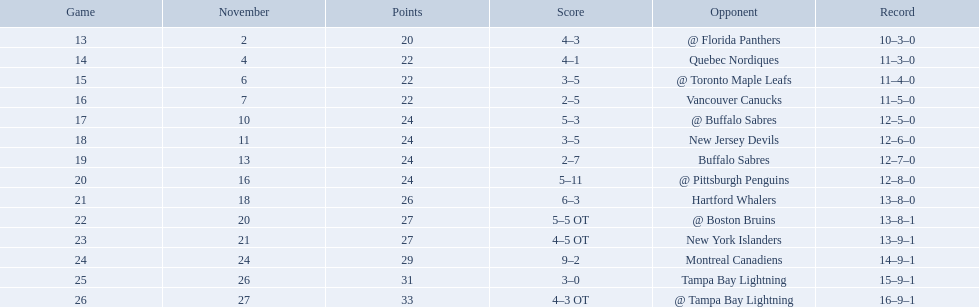What were the scores? @ Florida Panthers, 4–3, Quebec Nordiques, 4–1, @ Toronto Maple Leafs, 3–5, Vancouver Canucks, 2–5, @ Buffalo Sabres, 5–3, New Jersey Devils, 3–5, Buffalo Sabres, 2–7, @ Pittsburgh Penguins, 5–11, Hartford Whalers, 6–3, @ Boston Bruins, 5–5 OT, New York Islanders, 4–5 OT, Montreal Canadiens, 9–2, Tampa Bay Lightning, 3–0, @ Tampa Bay Lightning, 4–3 OT. What score was the closest? New York Islanders, 4–5 OT. What team had that score? New York Islanders. Who did the philadelphia flyers play in game 17? @ Buffalo Sabres. What was the score of the november 10th game against the buffalo sabres? 5–3. Which team in the atlantic division had less points than the philadelphia flyers? Tampa Bay Lightning. 